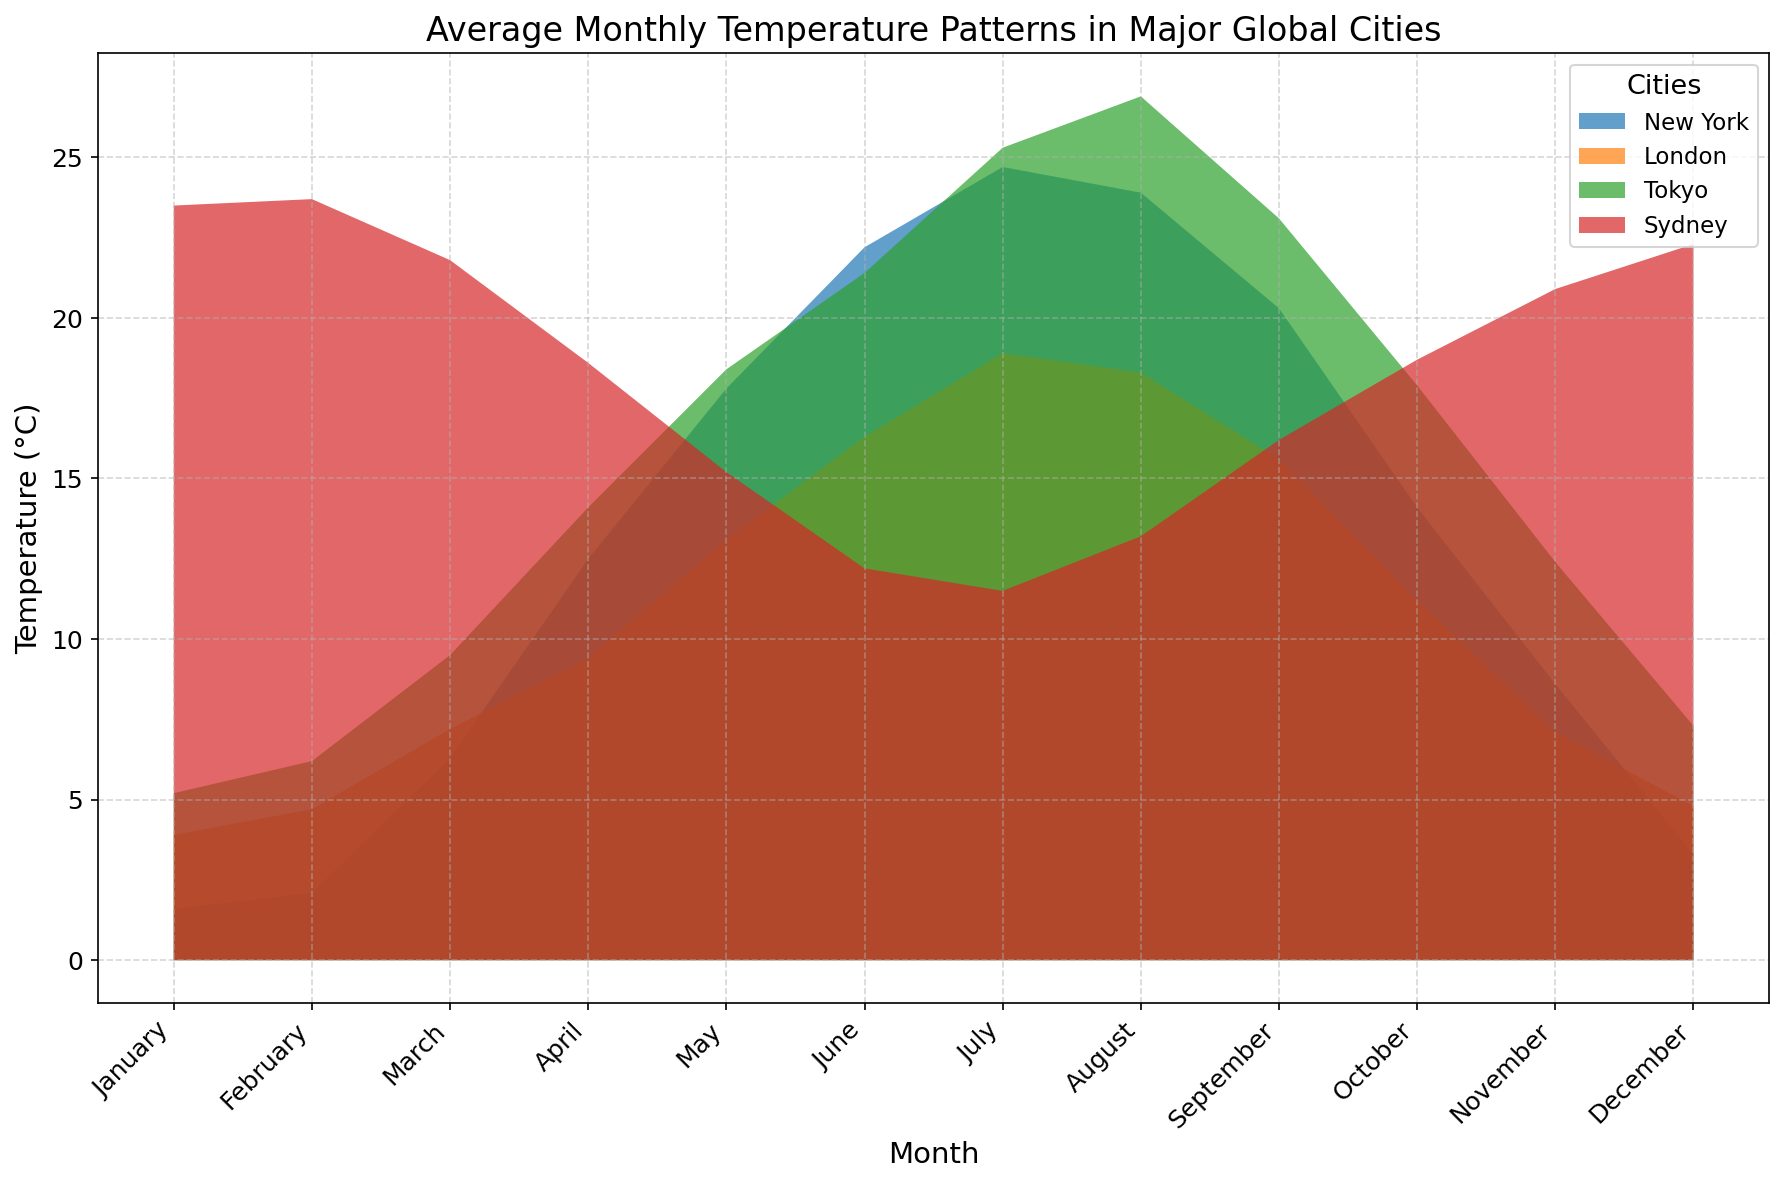Which city has the highest average temperature in July? According to the plot, by looking for the city area with the highest peak at July, it is Tokyo. The filled area representing Tokyo has the highest vertical level in July.
Answer: Tokyo Which month shows the smallest temperature difference between New York and London? We visually compare the heights of the areas for New York and London for each month. In January, the heights of the areas for both cities are very close, indicating they have similar temperatures in January compared to other months.
Answer: January What is the temperature difference between Sydney and New York in January? From the plot, identify the temperature for Sydney (23.5 °C) and New York (1.6 °C) in January and subtract New York's temperature from Sydney's. \( 23.5 - 1.6 = 21.9 \)
Answer: 21.9 °C Which city experiences the highest temperature in August? By examining the highest filled area in August, we see that Tokyo's area is the highest, indicating Tokyo has the highest temperature in August.
Answer: Tokyo How does the temperature in Tokyo in November compare to its temperature in May? Look at the height of the areas for Tokyo in November and May. It is clear that the area for May is much higher, indicating May is warmer.
Answer: May is warmer; Tokyo is cooler in November Which city experiences the greatest temperature range over the year? Look for the city whose area spans the most significant height difference from its lowest to its highest point. New York has the largest variation between its lowest point in January and highest point in July.
Answer: New York During which month is London's temperature closest to Sydney's? Identify where the areas representing London and Sydney have minimal height difference. In October, the areas for both cities are nearly at the same height.
Answer: October What is the average temperature for New York and London in February? Determine the temperatures for New York (2.1 °C) and London (4.7 °C) in February, add them, and divide by two. \( \frac{2.1 + 4.7}{2} = 3.4 \)
Answer: 3.4 °C Which city has the coolest average temperature in December? Examine the areas for all cities in December and find the lowest area. New York has the lowest filled area, indicating it is the coolest.
Answer: New York 